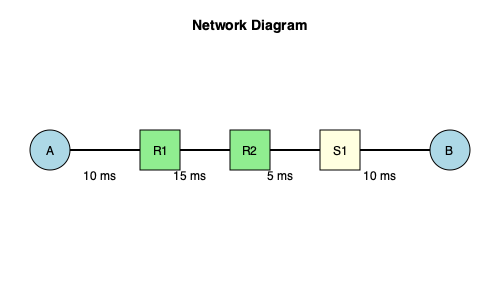In the given network diagram, a packet is sent from host A to host B. Assuming no queuing delays and negligible processing times at the devices, what is the total end-to-end delay for the packet to reach its destination? To calculate the total end-to-end delay for the packet, we need to sum up all the transmission delays along the path from host A to host B. Let's break it down step-by-step:

1. Host A to Router R1: 10 ms
2. Router R1 to Router R2: 15 ms
3. Router R2 to Switch S1: 5 ms
4. Switch S1 to Host B: 10 ms

The total end-to-end delay is the sum of these individual delays:

$$ \text{Total Delay} = 10 \text{ ms} + 15 \text{ ms} + 5 \text{ ms} + 10 \text{ ms} $$

$$ \text{Total Delay} = 40 \text{ ms} $$

Therefore, the total end-to-end delay for the packet to reach its destination is 40 ms.
Answer: 40 ms 